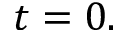Convert formula to latex. <formula><loc_0><loc_0><loc_500><loc_500>t = 0 .</formula> 